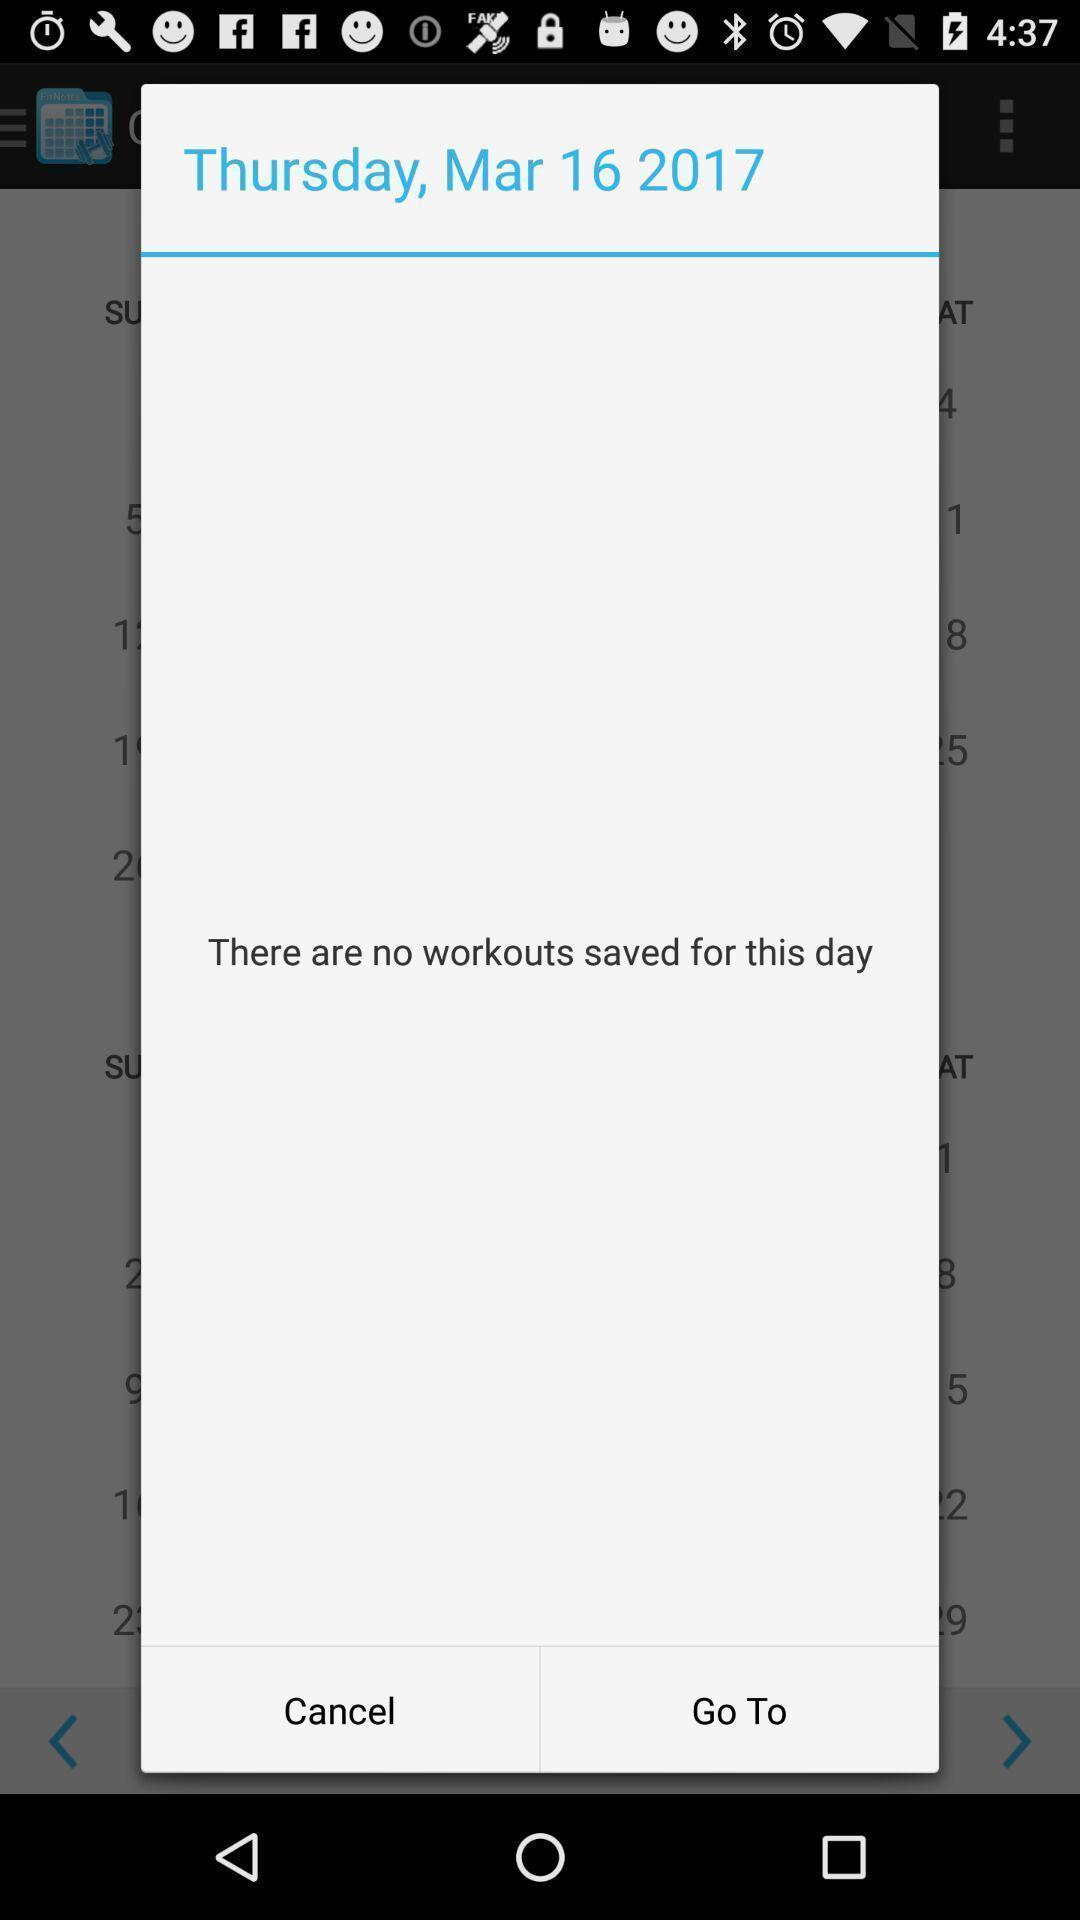Describe the key features of this screenshot. Pop-up for no workouts are saved on this day. 